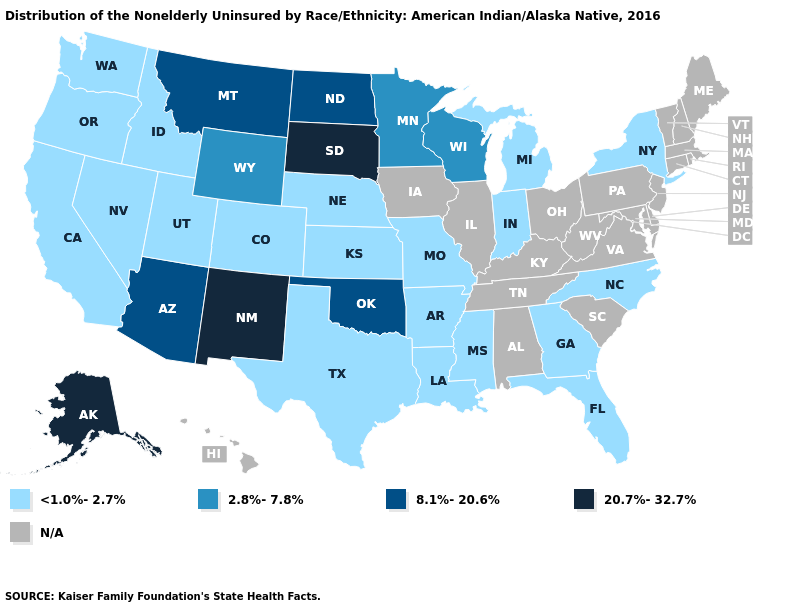Name the states that have a value in the range 2.8%-7.8%?
Write a very short answer. Minnesota, Wisconsin, Wyoming. Name the states that have a value in the range 2.8%-7.8%?
Short answer required. Minnesota, Wisconsin, Wyoming. Among the states that border Oklahoma , does Arkansas have the highest value?
Write a very short answer. No. What is the value of North Carolina?
Quick response, please. <1.0%-2.7%. Name the states that have a value in the range 2.8%-7.8%?
Be succinct. Minnesota, Wisconsin, Wyoming. Name the states that have a value in the range 20.7%-32.7%?
Short answer required. Alaska, New Mexico, South Dakota. Among the states that border Mississippi , which have the highest value?
Concise answer only. Arkansas, Louisiana. Does Missouri have the highest value in the MidWest?
Be succinct. No. Does the first symbol in the legend represent the smallest category?
Keep it brief. Yes. What is the lowest value in states that border Minnesota?
Write a very short answer. 2.8%-7.8%. What is the value of New Hampshire?
Answer briefly. N/A. Does Oklahoma have the lowest value in the South?
Short answer required. No. 